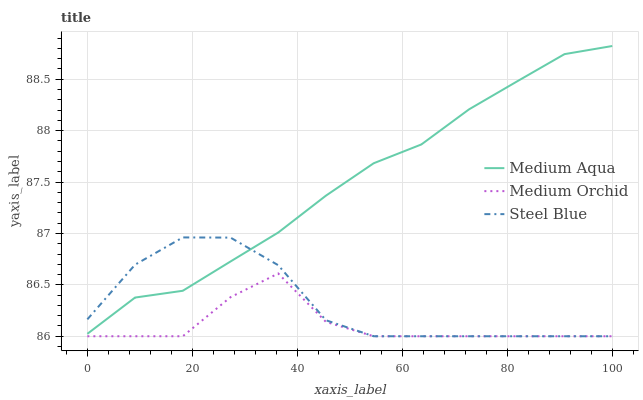Does Medium Orchid have the minimum area under the curve?
Answer yes or no. Yes. Does Medium Aqua have the maximum area under the curve?
Answer yes or no. Yes. Does Steel Blue have the minimum area under the curve?
Answer yes or no. No. Does Steel Blue have the maximum area under the curve?
Answer yes or no. No. Is Medium Aqua the smoothest?
Answer yes or no. Yes. Is Medium Orchid the roughest?
Answer yes or no. Yes. Is Steel Blue the smoothest?
Answer yes or no. No. Is Steel Blue the roughest?
Answer yes or no. No. Does Medium Orchid have the lowest value?
Answer yes or no. Yes. Does Medium Aqua have the lowest value?
Answer yes or no. No. Does Medium Aqua have the highest value?
Answer yes or no. Yes. Does Steel Blue have the highest value?
Answer yes or no. No. Is Medium Orchid less than Medium Aqua?
Answer yes or no. Yes. Is Medium Aqua greater than Medium Orchid?
Answer yes or no. Yes. Does Medium Orchid intersect Steel Blue?
Answer yes or no. Yes. Is Medium Orchid less than Steel Blue?
Answer yes or no. No. Is Medium Orchid greater than Steel Blue?
Answer yes or no. No. Does Medium Orchid intersect Medium Aqua?
Answer yes or no. No. 